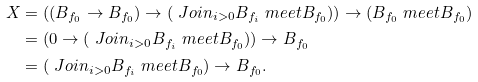<formula> <loc_0><loc_0><loc_500><loc_500>X & = \left ( ( B _ { f _ { 0 } } \rightarrow B _ { f _ { 0 } } ) \rightarrow ( \ J o i n _ { i > 0 } B _ { f _ { i } } \ m e e t B _ { f _ { 0 } } ) \right ) \rightarrow ( B _ { f _ { 0 } } \ m e e t B _ { f _ { 0 } } ) \\ & = \left ( 0 \rightarrow ( \ J o i n _ { i > 0 } B _ { f _ { i } } \ m e e t B _ { f _ { 0 } } ) \right ) \rightarrow B _ { f _ { 0 } } \\ & = ( \ J o i n _ { i > 0 } B _ { f _ { i } } \ m e e t B _ { f _ { 0 } } ) \rightarrow B _ { f _ { 0 } } .</formula> 